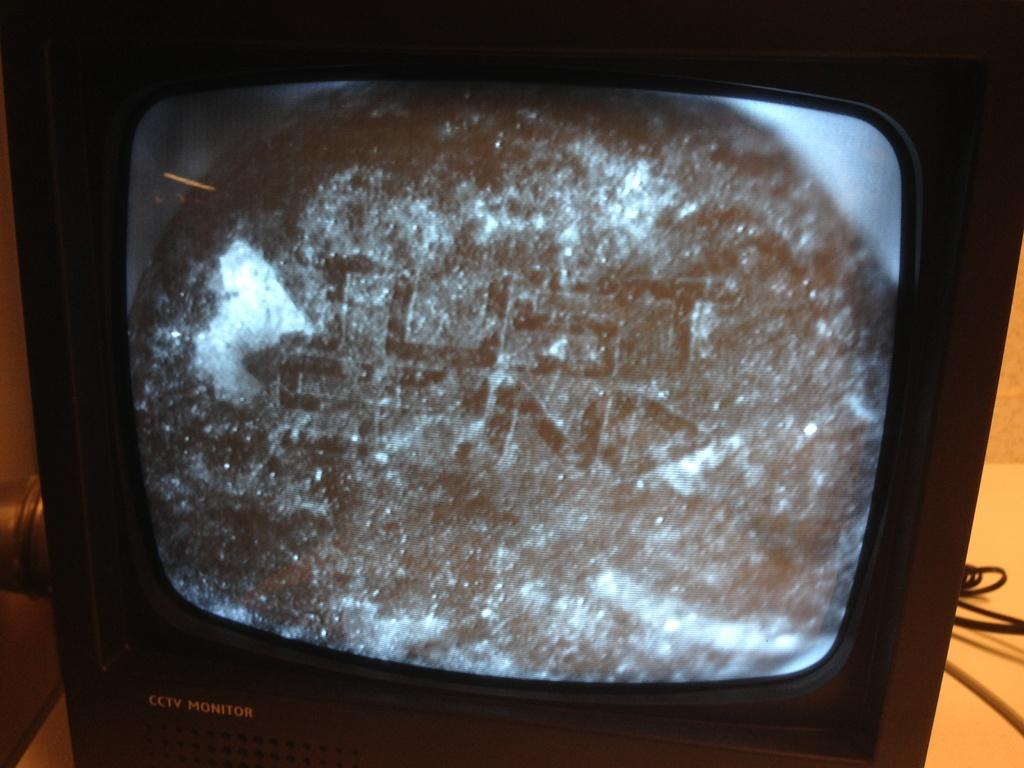Provide a one-sentence caption for the provided image. A small television serves as a cctv (closed circuit television) monitor. 